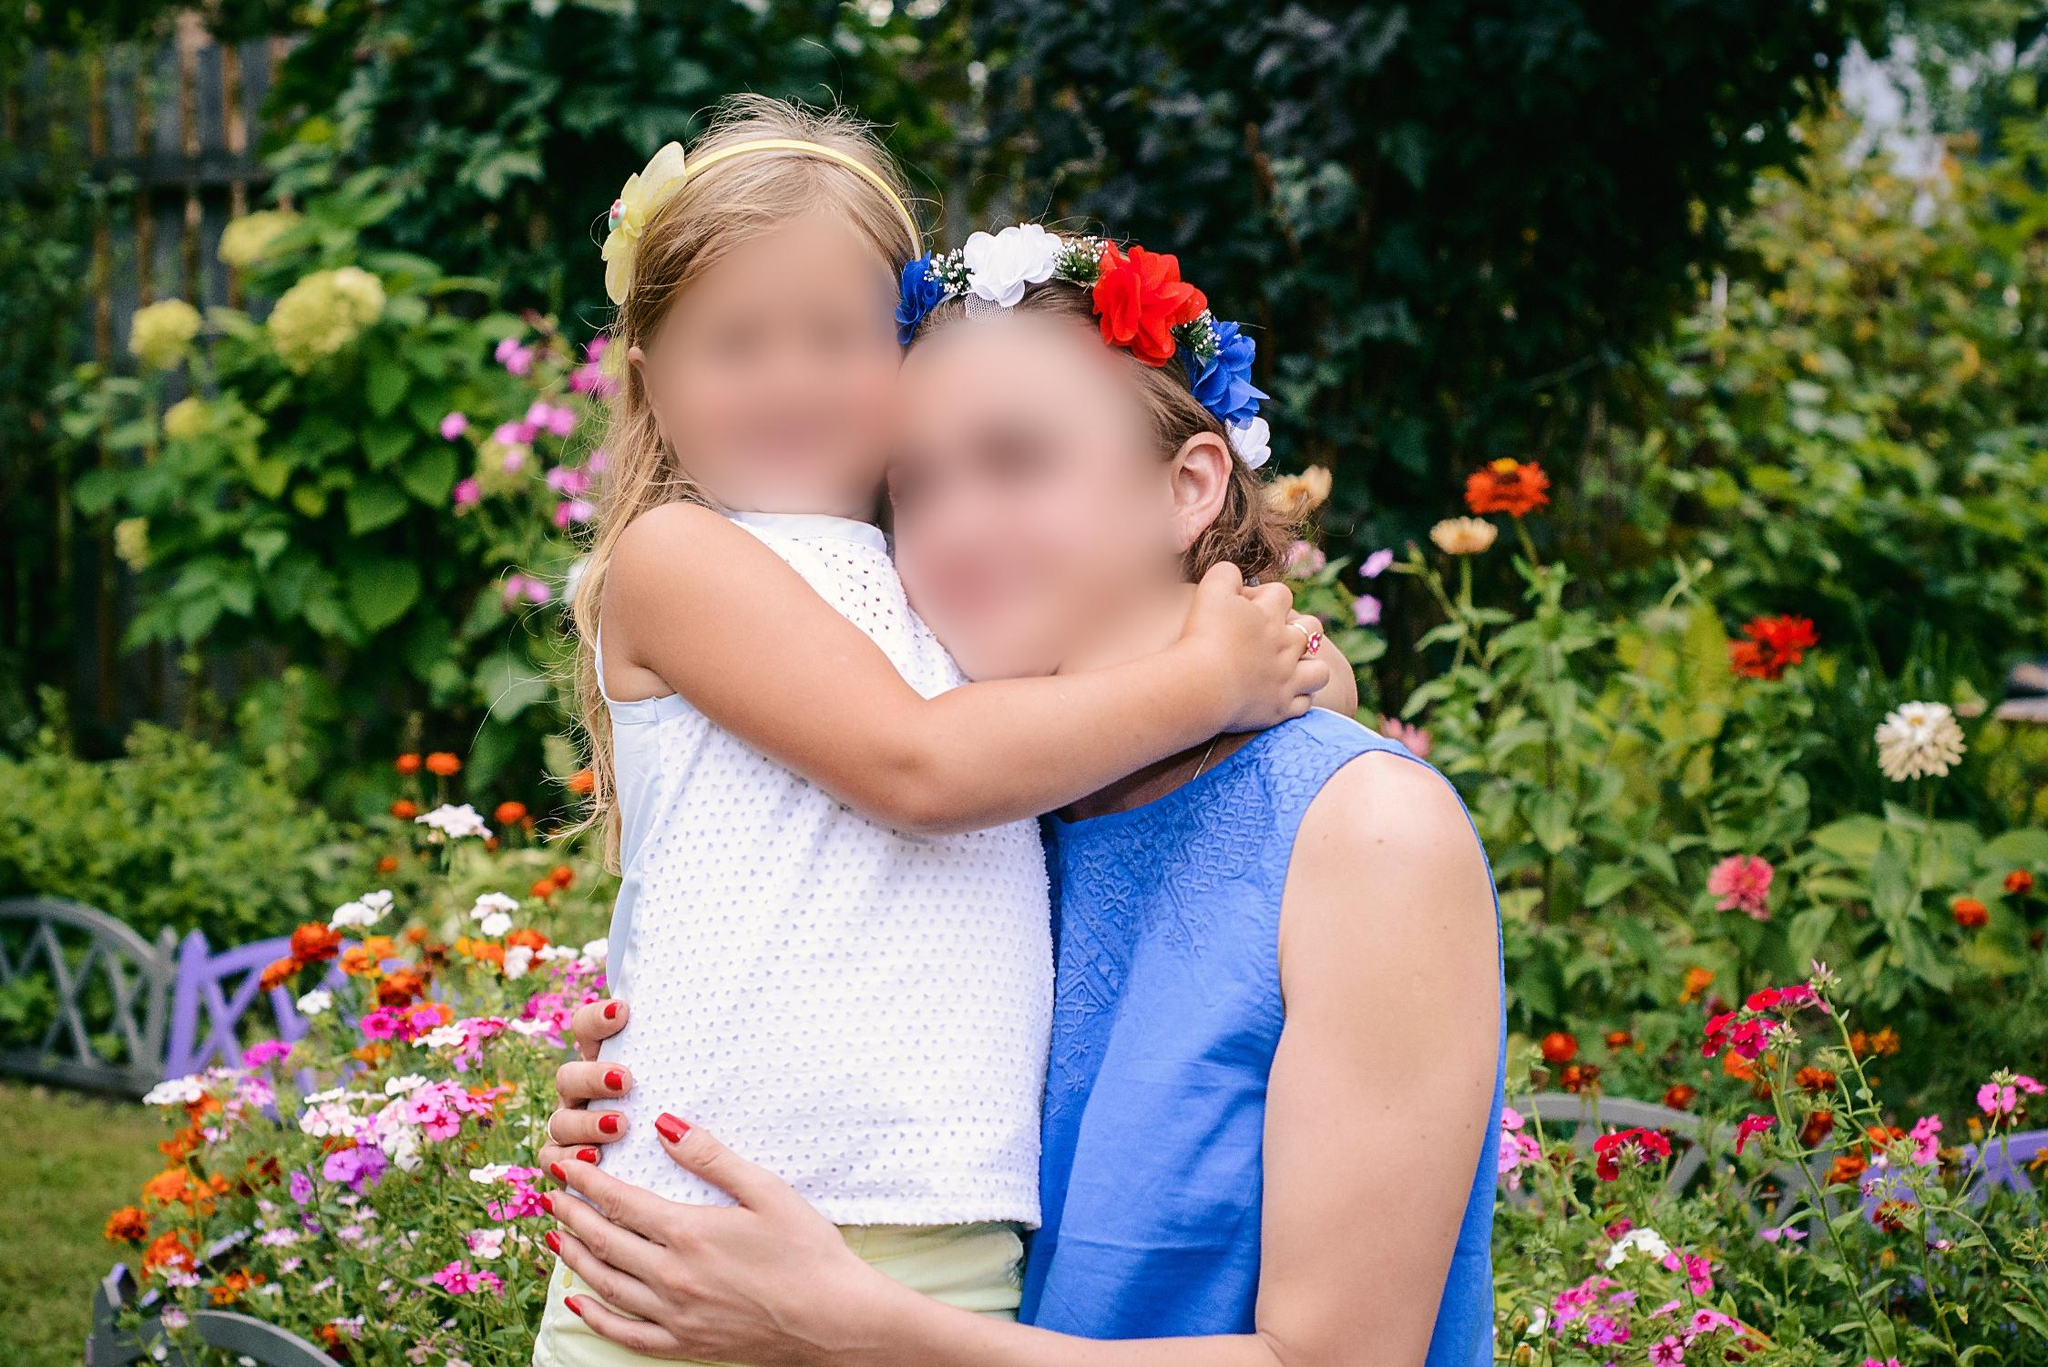Can you tell me more about the types of flowers visible in the background of the image? Certainly! The garden in the image boasts a rich assortment of flowers, including tall red blossoms possibly representing daisies or geraniums, and various shades of pink and orange flowers that might be petunias or zinnias. These flowers are commonly found in gardens designed to attract butterflies and create a colorful display throughout the growing season. What might be the occasion for wearing such decorative floral headbands? Floral headbands often signify celebration and joy, commonly worn at events like festivals, weddings, or garden parties. In this context, considering the garden setting and the dresses, it's likely a special family event, possibly a garden party or a smaller gathering like a birthday or family reunion where participants dress up to add to the festive atmosphere. 